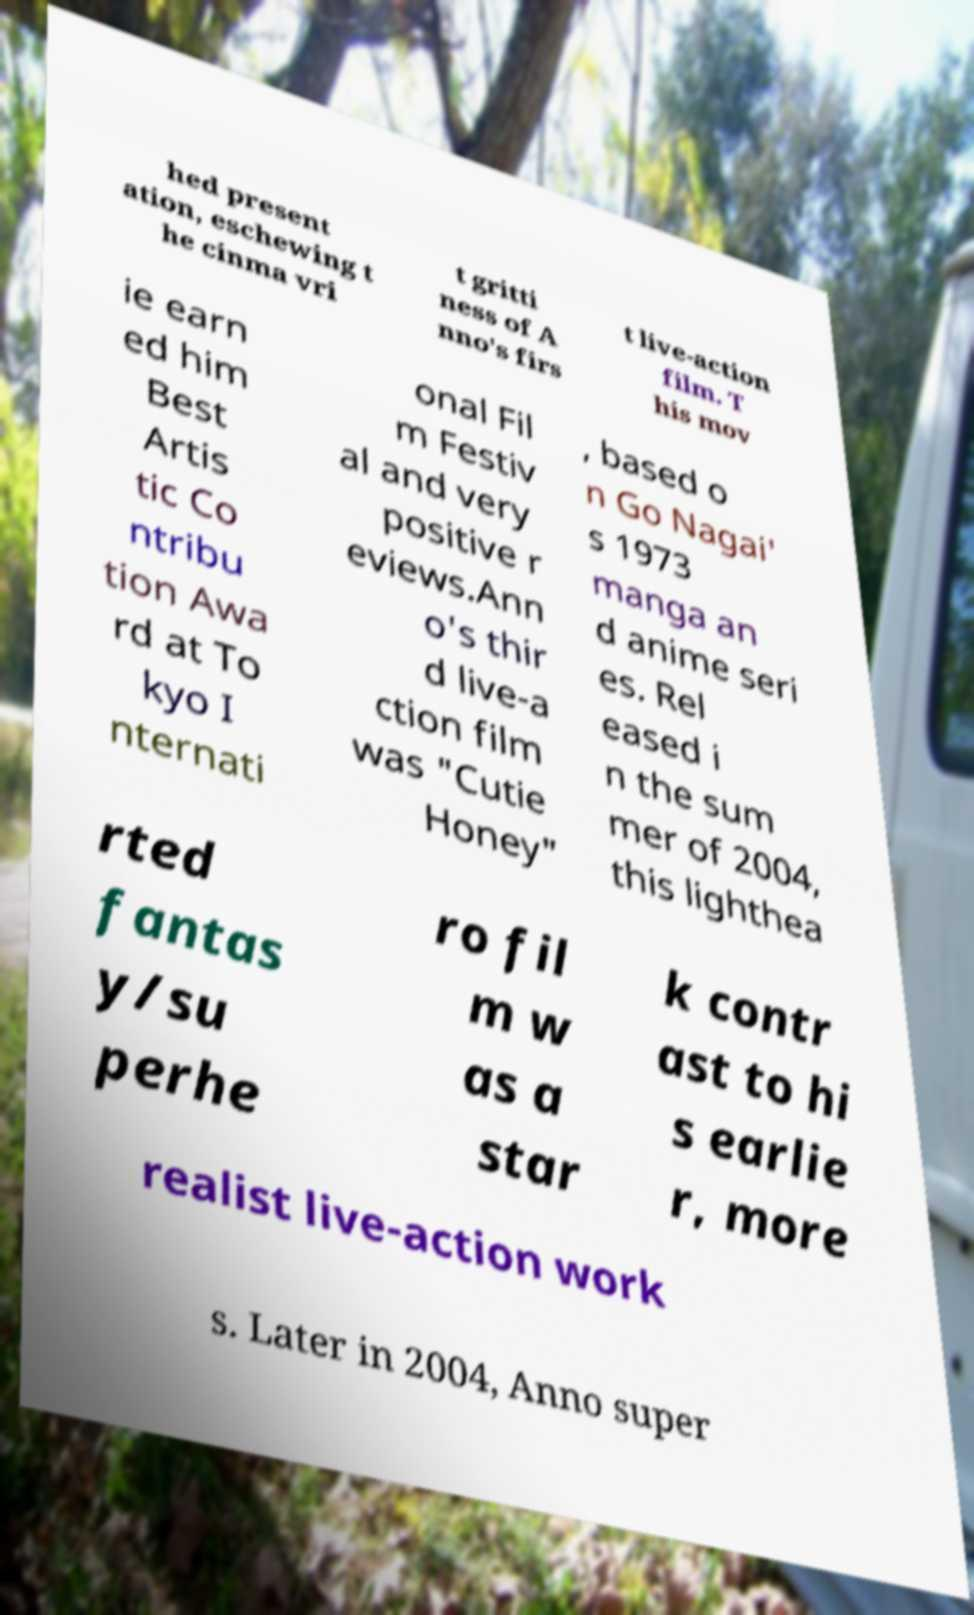For documentation purposes, I need the text within this image transcribed. Could you provide that? hed present ation, eschewing t he cinma vri t gritti ness of A nno's firs t live-action film. T his mov ie earn ed him Best Artis tic Co ntribu tion Awa rd at To kyo I nternati onal Fil m Festiv al and very positive r eviews.Ann o's thir d live-a ction film was "Cutie Honey" , based o n Go Nagai' s 1973 manga an d anime seri es. Rel eased i n the sum mer of 2004, this lighthea rted fantas y/su perhe ro fil m w as a star k contr ast to hi s earlie r, more realist live-action work s. Later in 2004, Anno super 